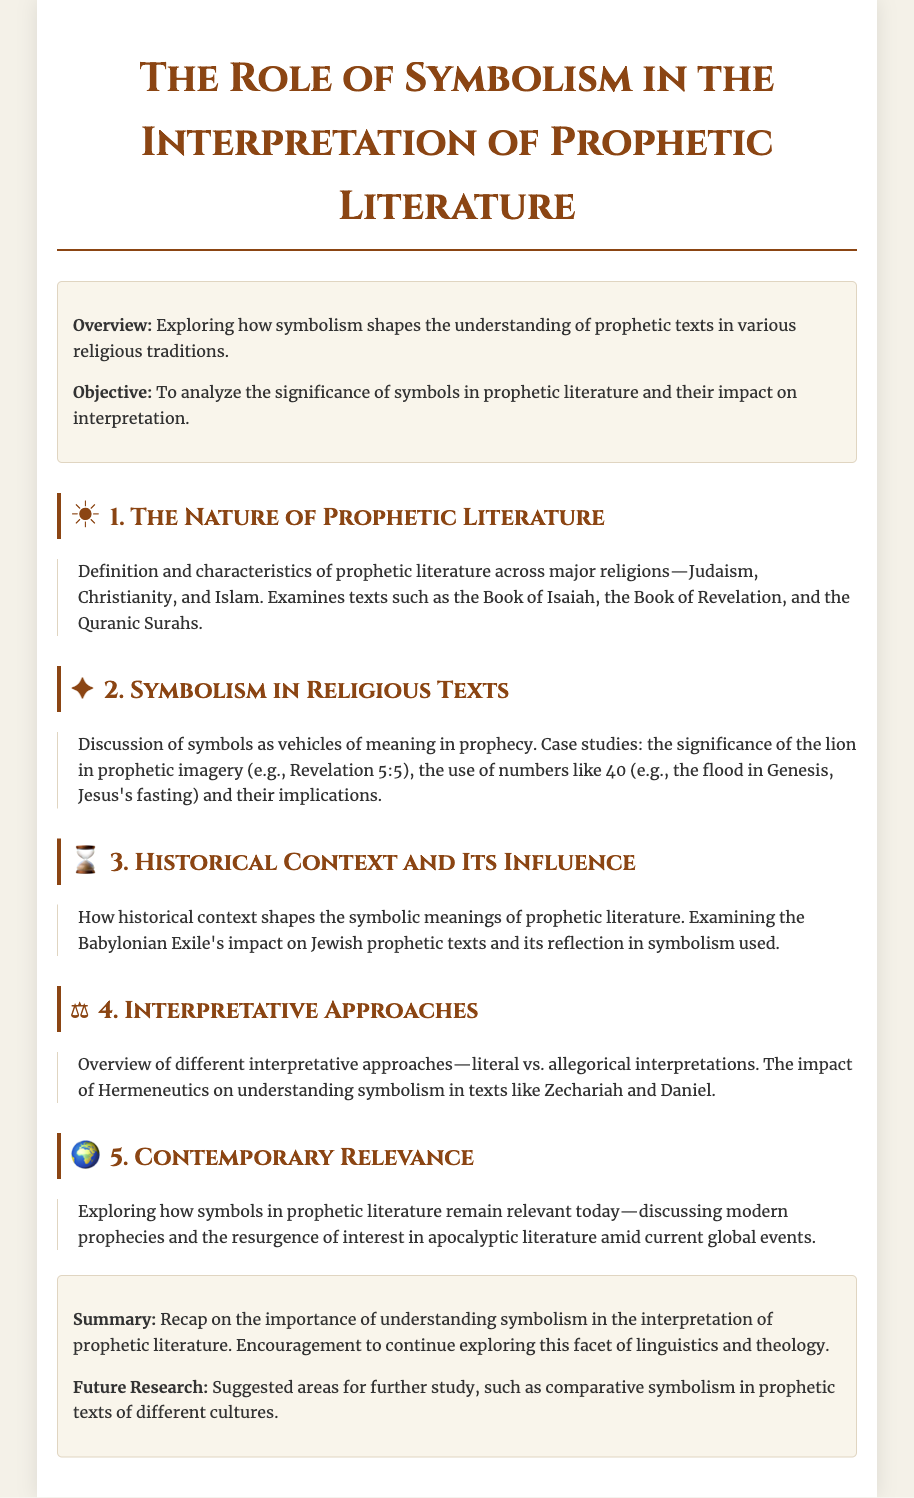What is the title of the document? The title of the document is indicated at the top of the rendered page.
Answer: The Role of Symbolism in the Interpretation of Prophetic Literature What are the three major religions mentioned? The document lists the major religions related to prophetic literature in the first section.
Answer: Judaism, Christianity, Islam Which prophetic text is referenced in the case study about the lion? The document mentions a specific prophetic text associated with the symbolism of the lion.
Answer: Revelation 5:5 What is the significance of the number 40 discussed in the document? The document highlights the use of the number 40 in various contexts in prophetic literature.
Answer: Implications of the flood in Genesis, Jesus's fasting What major historical event is analyzed in relation to Jewish prophetic texts? The document points out a historical context influencing the symbols in prophetic literature.
Answer: Babylonian Exile What are the two interpretative approaches mentioned? The document offers an overview of different interpretative methods regarding prophetic symbolism.
Answer: Literal vs. allegorical interpretations What is the contemporary relevance of symbolic literature according to the document? The document discusses the impact of current events on the interpretation of prophetic literature.
Answer: Modern prophecies and apocalyptic literature What encouragement is given in the conclusion? The conclusion summarizes the purpose of the document and offers encouragement for further exploration.
Answer: Continue exploring this facet of linguistics and theology 